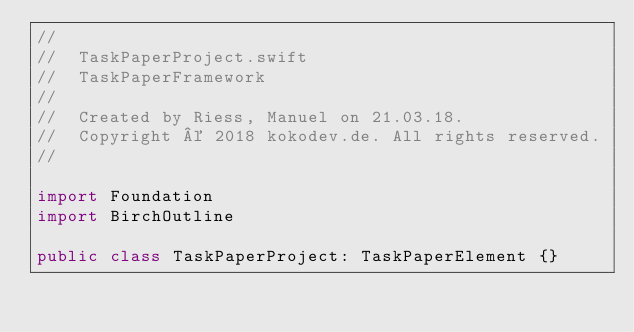Convert code to text. <code><loc_0><loc_0><loc_500><loc_500><_Swift_>//
//  TaskPaperProject.swift
//  TaskPaperFramework
//
//  Created by Riess, Manuel on 21.03.18.
//  Copyright © 2018 kokodev.de. All rights reserved.
//

import Foundation
import BirchOutline

public class TaskPaperProject: TaskPaperElement {}
</code> 